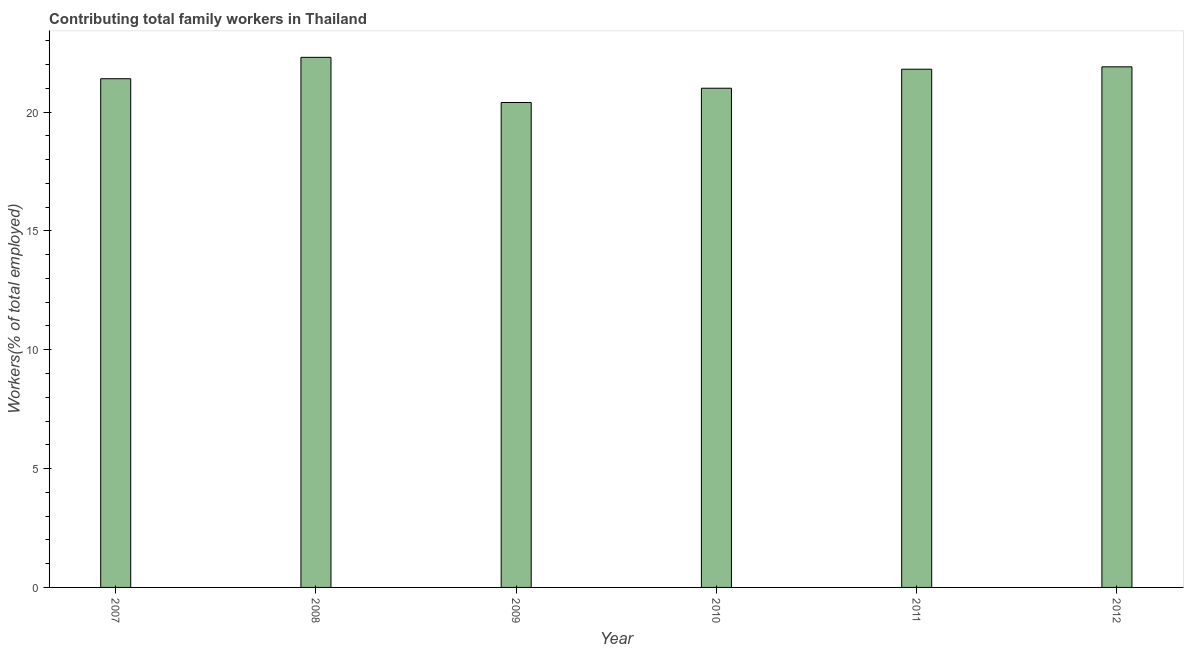Does the graph contain grids?
Keep it short and to the point. No. What is the title of the graph?
Offer a very short reply. Contributing total family workers in Thailand. What is the label or title of the Y-axis?
Keep it short and to the point. Workers(% of total employed). What is the contributing family workers in 2012?
Give a very brief answer. 21.9. Across all years, what is the maximum contributing family workers?
Offer a terse response. 22.3. Across all years, what is the minimum contributing family workers?
Provide a succinct answer. 20.4. In which year was the contributing family workers maximum?
Your answer should be compact. 2008. In which year was the contributing family workers minimum?
Keep it short and to the point. 2009. What is the sum of the contributing family workers?
Offer a terse response. 128.8. What is the average contributing family workers per year?
Offer a very short reply. 21.47. What is the median contributing family workers?
Provide a short and direct response. 21.6. Do a majority of the years between 2009 and 2007 (inclusive) have contributing family workers greater than 11 %?
Keep it short and to the point. Yes. What is the ratio of the contributing family workers in 2007 to that in 2009?
Provide a short and direct response. 1.05. Is the difference between the contributing family workers in 2011 and 2012 greater than the difference between any two years?
Your response must be concise. No. What is the difference between the highest and the lowest contributing family workers?
Give a very brief answer. 1.9. Are all the bars in the graph horizontal?
Keep it short and to the point. No. What is the difference between two consecutive major ticks on the Y-axis?
Your response must be concise. 5. What is the Workers(% of total employed) in 2007?
Provide a succinct answer. 21.4. What is the Workers(% of total employed) in 2008?
Provide a succinct answer. 22.3. What is the Workers(% of total employed) in 2009?
Provide a short and direct response. 20.4. What is the Workers(% of total employed) of 2010?
Give a very brief answer. 21. What is the Workers(% of total employed) in 2011?
Make the answer very short. 21.8. What is the Workers(% of total employed) of 2012?
Provide a succinct answer. 21.9. What is the difference between the Workers(% of total employed) in 2007 and 2008?
Your answer should be very brief. -0.9. What is the difference between the Workers(% of total employed) in 2007 and 2009?
Your answer should be very brief. 1. What is the difference between the Workers(% of total employed) in 2008 and 2009?
Provide a short and direct response. 1.9. What is the difference between the Workers(% of total employed) in 2008 and 2011?
Provide a short and direct response. 0.5. What is the difference between the Workers(% of total employed) in 2008 and 2012?
Provide a succinct answer. 0.4. What is the difference between the Workers(% of total employed) in 2009 and 2011?
Ensure brevity in your answer.  -1.4. What is the difference between the Workers(% of total employed) in 2010 and 2011?
Ensure brevity in your answer.  -0.8. What is the difference between the Workers(% of total employed) in 2011 and 2012?
Your answer should be very brief. -0.1. What is the ratio of the Workers(% of total employed) in 2007 to that in 2009?
Give a very brief answer. 1.05. What is the ratio of the Workers(% of total employed) in 2007 to that in 2010?
Your response must be concise. 1.02. What is the ratio of the Workers(% of total employed) in 2007 to that in 2012?
Keep it short and to the point. 0.98. What is the ratio of the Workers(% of total employed) in 2008 to that in 2009?
Keep it short and to the point. 1.09. What is the ratio of the Workers(% of total employed) in 2008 to that in 2010?
Your response must be concise. 1.06. What is the ratio of the Workers(% of total employed) in 2009 to that in 2011?
Offer a very short reply. 0.94. What is the ratio of the Workers(% of total employed) in 2009 to that in 2012?
Ensure brevity in your answer.  0.93. What is the ratio of the Workers(% of total employed) in 2010 to that in 2011?
Keep it short and to the point. 0.96. What is the ratio of the Workers(% of total employed) in 2011 to that in 2012?
Ensure brevity in your answer.  0.99. 